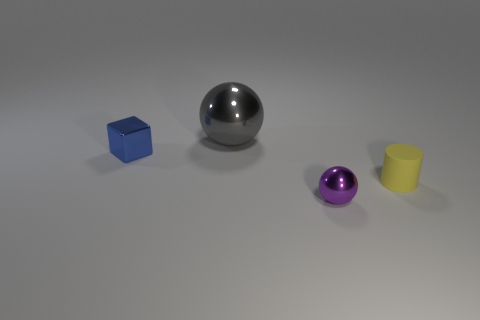What is the size of the ball that is the same material as the purple object?
Provide a short and direct response. Large. What number of other metallic objects are the same shape as the tiny purple metallic thing?
Offer a very short reply. 1. What number of gray matte cylinders are there?
Ensure brevity in your answer.  0. There is a metal thing behind the blue metal cube; is its shape the same as the purple thing?
Ensure brevity in your answer.  Yes. There is a purple thing that is the same size as the yellow rubber cylinder; what material is it?
Provide a short and direct response. Metal. Is there a purple ball made of the same material as the blue thing?
Offer a very short reply. Yes. Is the shape of the gray shiny thing the same as the object that is in front of the matte object?
Offer a very short reply. Yes. How many objects are both to the left of the tiny yellow rubber cylinder and right of the big ball?
Your answer should be compact. 1. Is the gray thing made of the same material as the thing in front of the tiny matte cylinder?
Offer a very short reply. Yes. Are there an equal number of rubber cylinders to the left of the big gray metal object and big gray metallic cubes?
Keep it short and to the point. Yes. 